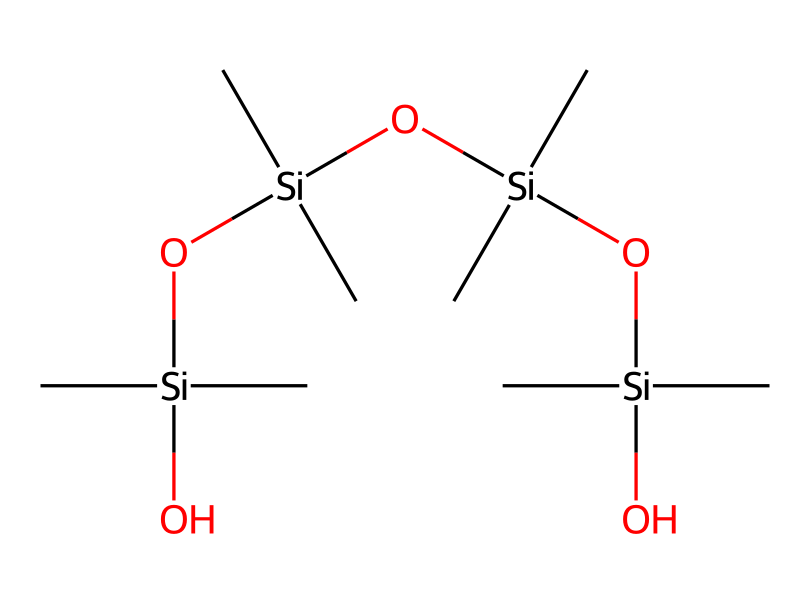How many silicon atoms are present in this structure? By analyzing the SMILES representation, we can identify the silicon atoms by locating the "Si" symbols. In this case, there are four occurrences of "Si" in the structure.
Answer: four What is the main functional group in this chemical? The presence of the "O" connected to silicon indicates the presence of siloxane groups (-Si-O-Si-), which are characteristic of polydimethylsiloxane.
Answer: siloxane How many total carbon atoms are in this molecule? Count the number of "C" symbols in the SMILES representation. There are eight carbon atoms connected, contributing to the total count.
Answer: eight What type of polymer is represented by this chemical structure? The structure showcases a repeating unit of siloxane, characteristic of polysiloxanes. Given the repeating nature and structure, it is classified as a silicone polymer.
Answer: silicone What is the approximate molecular weight of polydimethylsiloxane? To derive the molecular weight, account for the atomic weights of carbon, silicon, and oxygen present in the structure. The weights of each atom can be summed based on their count. The total is approximately 400 grams per mole.
Answer: 400 grams per mole Does this molecule exhibit high thermal stability? The alternating silicon and oxygen in the backbone of polydimethylsiloxane contributes to its thermal stability, thus making it suitable for high-temperature applications in thermal control coatings.
Answer: yes How does the structure contribute to its flexibility? The Si-O bonds are relatively flexible compared to C-C bonds, allowing the polymer to have a rubber-like quality. This flexibility is crucial for its application in spacecraft materials.
Answer: it has flexible Si-O bonds 